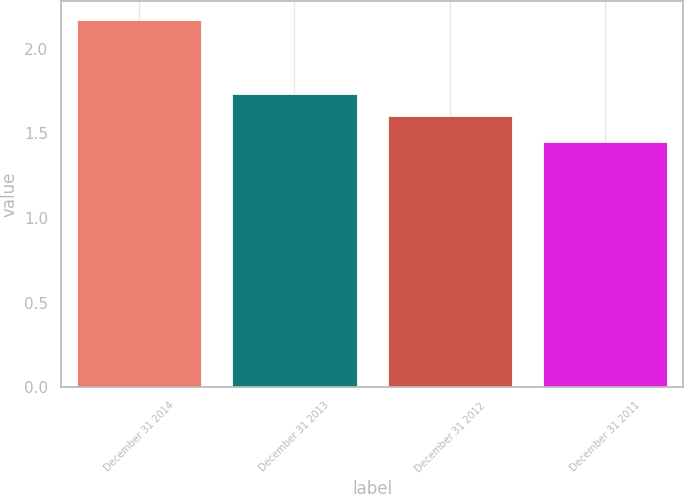<chart> <loc_0><loc_0><loc_500><loc_500><bar_chart><fcel>December 31 2014<fcel>December 31 2013<fcel>December 31 2012<fcel>December 31 2011<nl><fcel>2.17<fcel>1.73<fcel>1.6<fcel>1.45<nl></chart> 